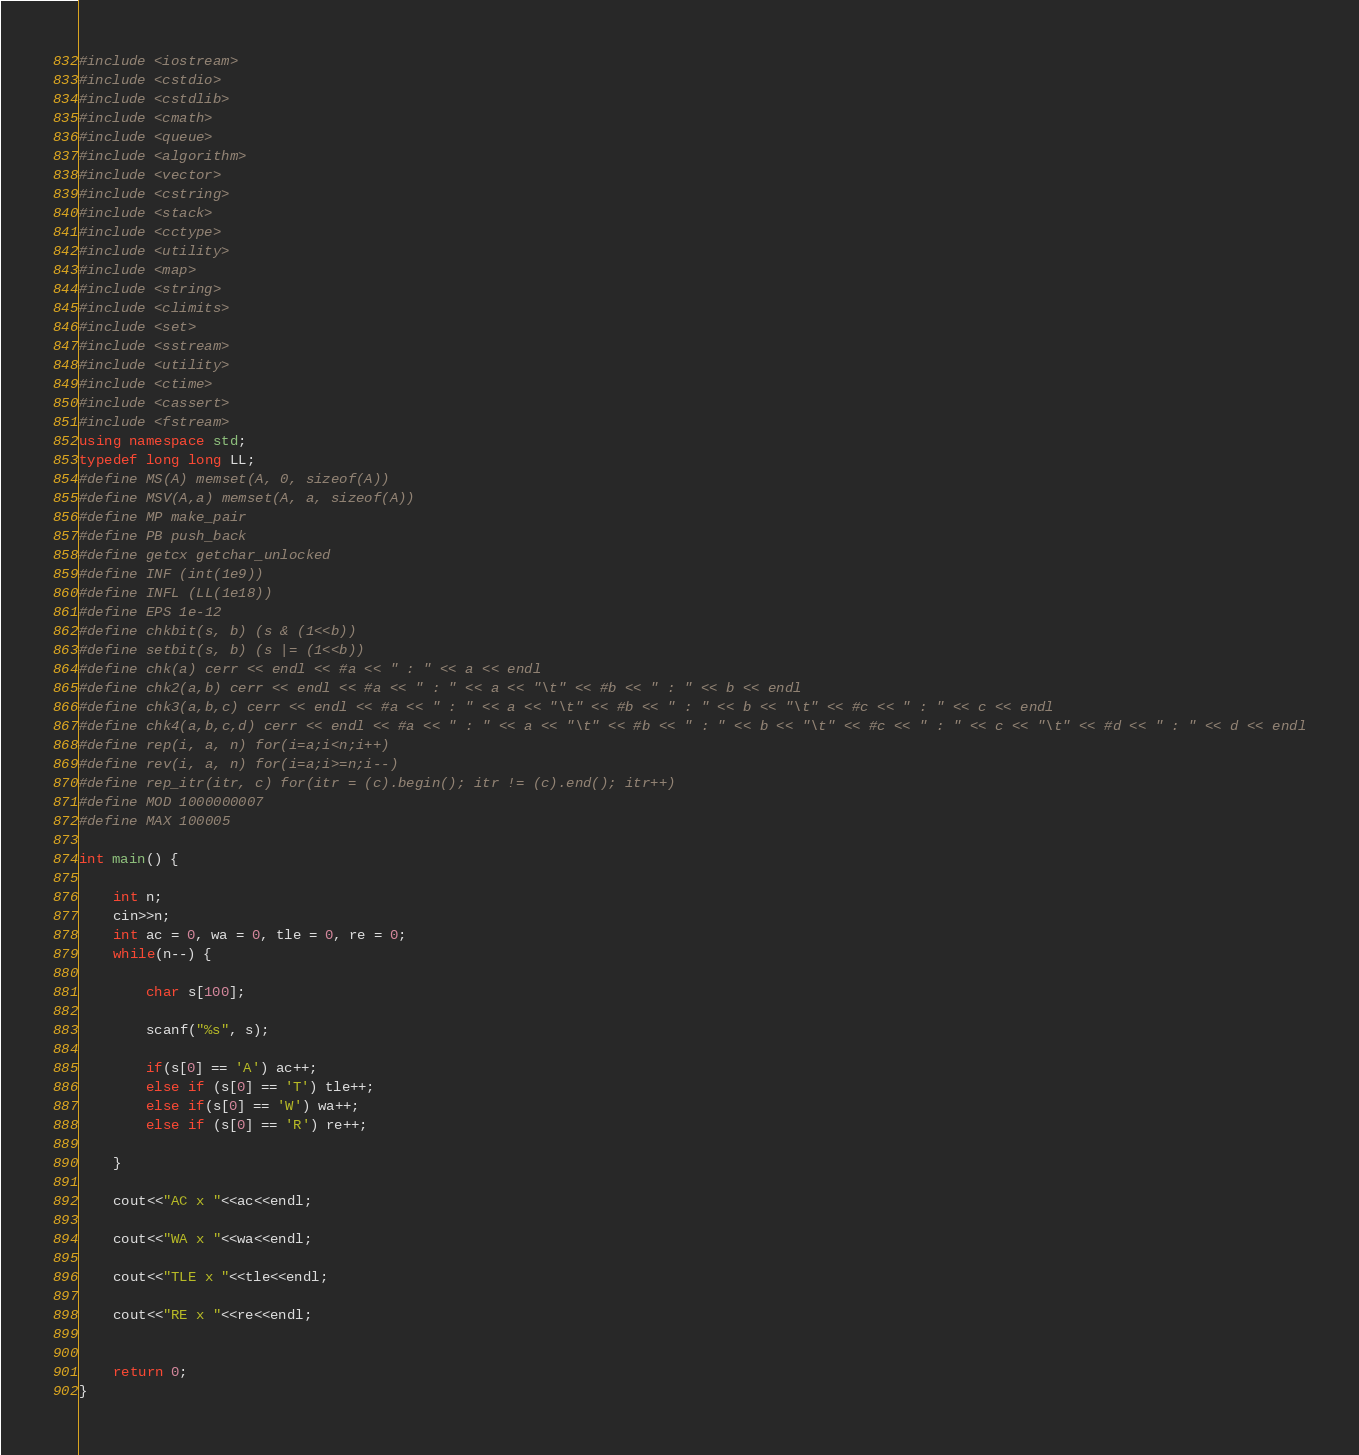<code> <loc_0><loc_0><loc_500><loc_500><_C++_>#include <iostream>
#include <cstdio>
#include <cstdlib>
#include <cmath>
#include <queue>
#include <algorithm>
#include <vector>
#include <cstring>
#include <stack>
#include <cctype>
#include <utility>
#include <map>
#include <string>
#include <climits>
#include <set>
#include <sstream>
#include <utility>
#include <ctime>
#include <cassert>
#include <fstream>
using namespace std;
typedef long long LL;
#define MS(A) memset(A, 0, sizeof(A))
#define MSV(A,a) memset(A, a, sizeof(A))
#define MP make_pair
#define PB push_back
#define getcx getchar_unlocked
#define INF (int(1e9))
#define INFL (LL(1e18))
#define EPS 1e-12
#define chkbit(s, b) (s & (1<<b))
#define setbit(s, b) (s |= (1<<b))
#define chk(a) cerr << endl << #a << " : " << a << endl
#define chk2(a,b) cerr << endl << #a << " : " << a << "\t" << #b << " : " << b << endl
#define chk3(a,b,c) cerr << endl << #a << " : " << a << "\t" << #b << " : " << b << "\t" << #c << " : " << c << endl
#define chk4(a,b,c,d) cerr << endl << #a << " : " << a << "\t" << #b << " : " << b << "\t" << #c << " : " << c << "\t" << #d << " : " << d << endl
#define rep(i, a, n) for(i=a;i<n;i++)
#define rev(i, a, n) for(i=a;i>=n;i--)
#define rep_itr(itr, c) for(itr = (c).begin(); itr != (c).end(); itr++)
#define MOD 1000000007
#define MAX 100005

int main() {

	int n;
	cin>>n;
	int ac = 0, wa = 0, tle = 0, re = 0;
	while(n--) {

		char s[100];
	
		scanf("%s", s);

		if(s[0] == 'A') ac++;
		else if (s[0] == 'T') tle++;
		else if(s[0] == 'W') wa++;
		else if (s[0] == 'R') re++;

	}

	cout<<"AC x "<<ac<<endl;

	cout<<"WA x "<<wa<<endl;

	cout<<"TLE x "<<tle<<endl;

	cout<<"RE x "<<re<<endl;


	return 0;
}</code> 